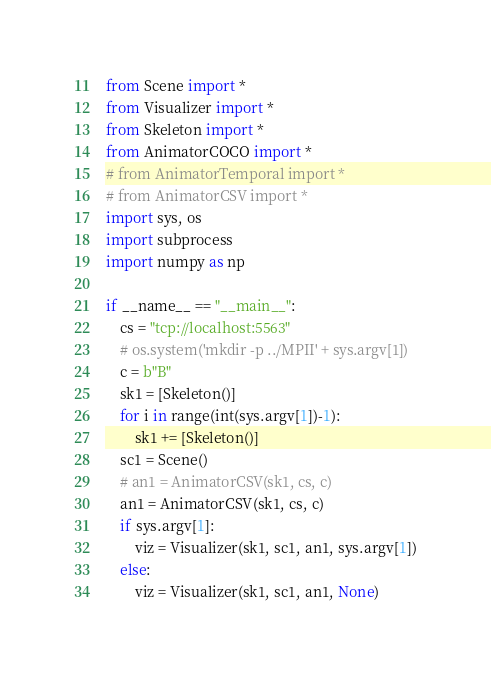Convert code to text. <code><loc_0><loc_0><loc_500><loc_500><_Python_>from Scene import *
from Visualizer import *
from Skeleton import *
from AnimatorCOCO import *
# from AnimatorTemporal import *
# from AnimatorCSV import *
import sys, os
import subprocess
import numpy as np

if __name__ == "__main__":
    cs = "tcp://localhost:5563"
    # os.system('mkdir -p ../MPII' + sys.argv[1])
    c = b"B"
    sk1 = [Skeleton()]
    for i in range(int(sys.argv[1])-1):
        sk1 += [Skeleton()]
    sc1 = Scene()
    # an1 = AnimatorCSV(sk1, cs, c)
    an1 = AnimatorCSV(sk1, cs, c)
    if sys.argv[1]:
        viz = Visualizer(sk1, sc1, an1, sys.argv[1])
    else:
        viz = Visualizer(sk1, sc1, an1, None)
</code> 